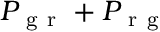Convert formula to latex. <formula><loc_0><loc_0><loc_500><loc_500>P _ { g r } + P _ { r g }</formula> 